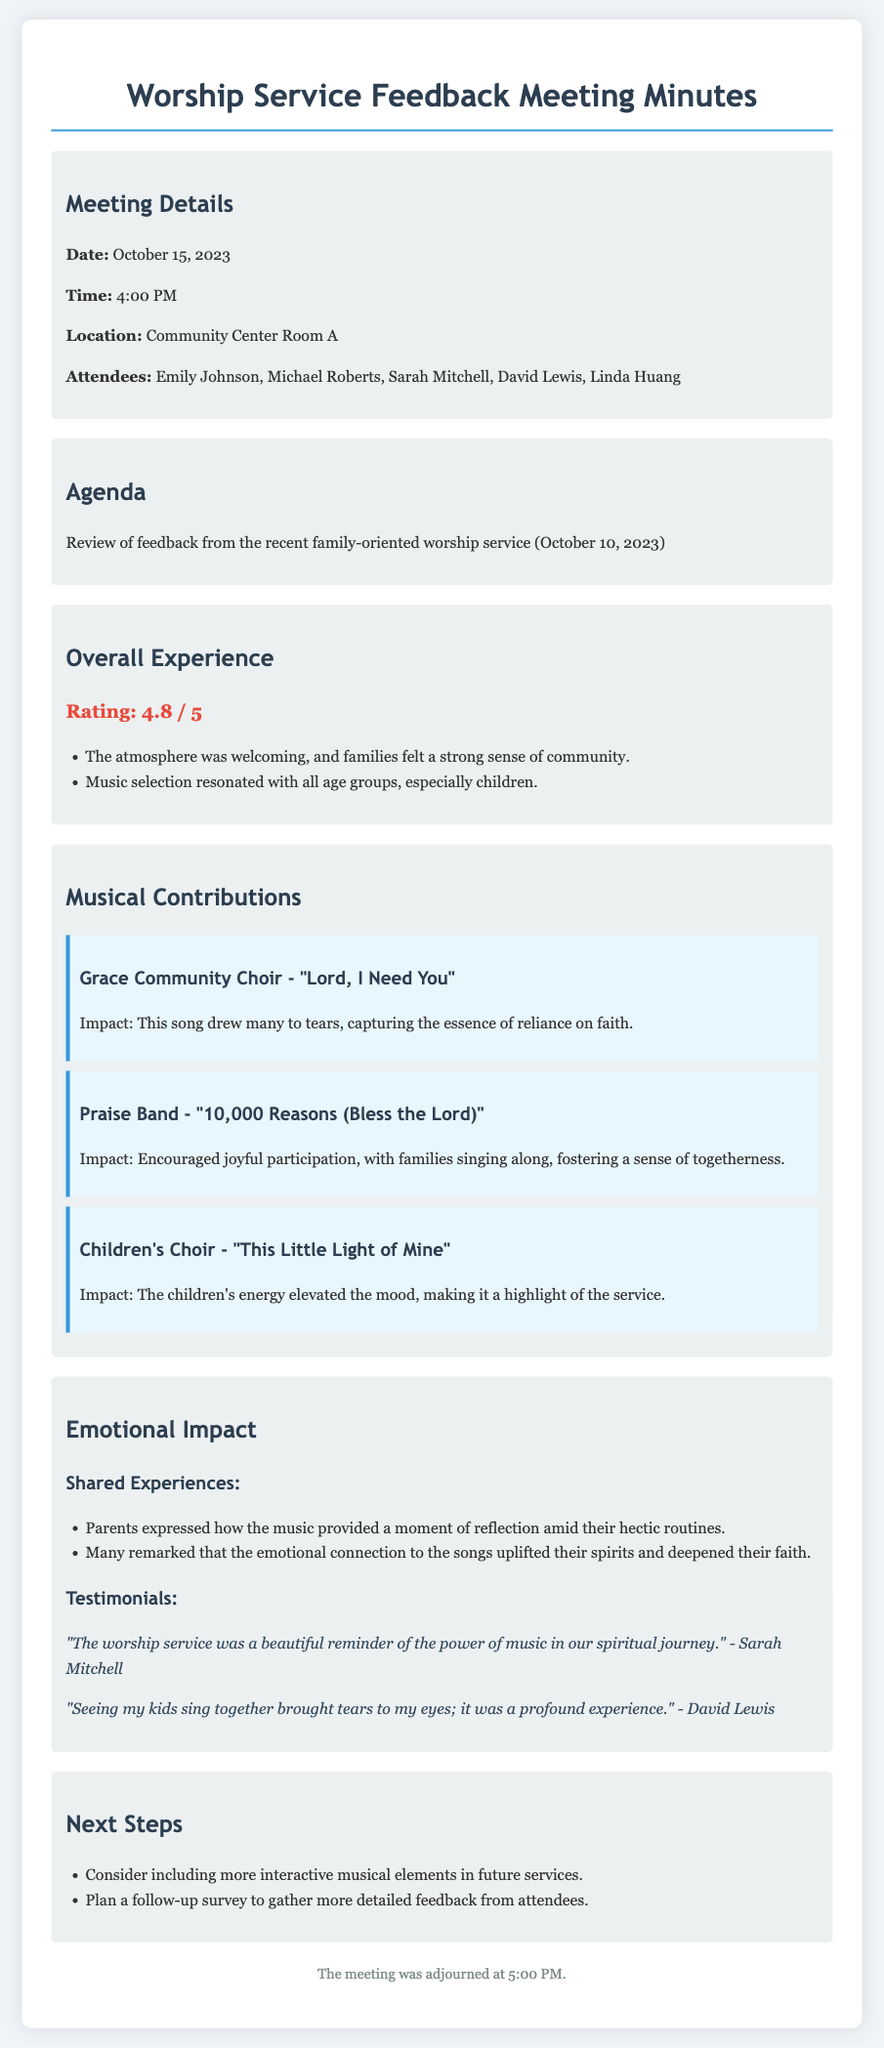What is the date of the meeting? The date of the meeting is stated at the beginning of the document.
Answer: October 15, 2023 What was the rating of the overall experience? The overall experience rating is mentioned in the document section titled "Overall Experience."
Answer: 4.8 / 5 Which choir performed "This Little Light of Mine"? The document specifies which choir performed this song under the "Musical Contributions" section.
Answer: Children's Choir What emotional impact did parents report from the music? Parents expressed their feelings in the section on "Emotional Impact."
Answer: Reflection Who provided a testimonial about the beauty of the worship service? The testimonials are located in the "Emotional Impact" section, indicating who shared their experience.
Answer: Sarah Mitchell What is one next step mentioned in the document? The "Next Steps" section describes potential actions based on feedback from the worship service.
Answer: Interactive musical elements How long did the meeting last? The meeting duration can be inferred from the start and adjournment time.
Answer: 1 hour What was the primary purpose of the meeting? The agenda clearly outlines what the meeting aimed to achieve.
Answer: Review feedback 